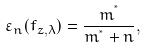<formula> <loc_0><loc_0><loc_500><loc_500>\varepsilon _ { n } ( f _ { z , \lambda } ) = \frac { m ^ { ^ { * } } } { m ^ { ^ { * } } + n } ,</formula> 